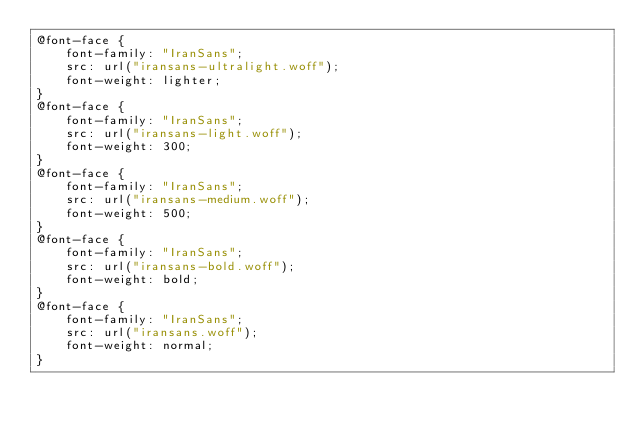<code> <loc_0><loc_0><loc_500><loc_500><_CSS_>@font-face {
    font-family: "IranSans";
    src: url("iransans-ultralight.woff");
    font-weight: lighter;
}
@font-face {
    font-family: "IranSans";
    src: url("iransans-light.woff");
    font-weight: 300;
}
@font-face {
    font-family: "IranSans";
    src: url("iransans-medium.woff");
    font-weight: 500;
}
@font-face {
    font-family: "IranSans";
    src: url("iransans-bold.woff");
    font-weight: bold;
}
@font-face {
    font-family: "IranSans";
    src: url("iransans.woff");
    font-weight: normal;
}
</code> 